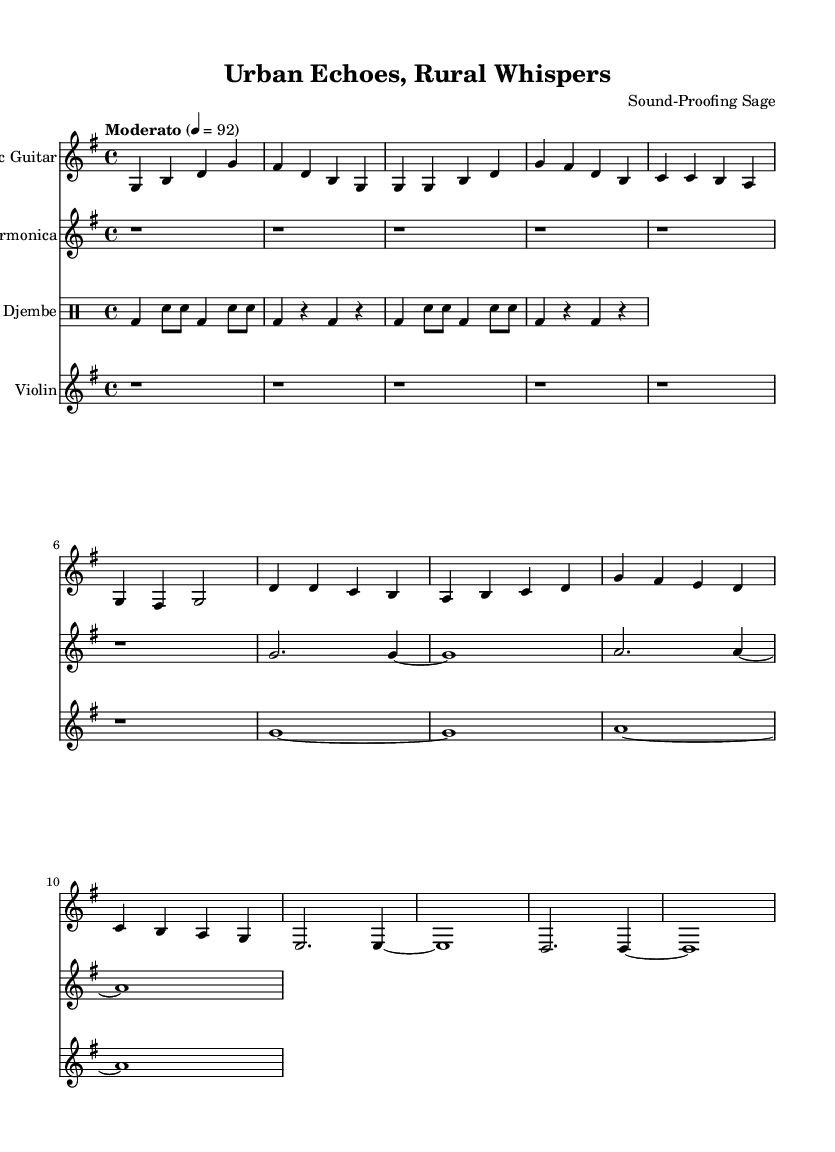What is the key signature of this music? The key signature shows one sharp, which indicates that the music is in G major.
Answer: G major What is the time signature of this music? The time signature is indicated as 4/4, meaning there are four beats in each measure and the quarter note gets one beat.
Answer: 4/4 What is the tempo marking in this piece? The tempo marking states "Moderato" with a metronome marking of quarter note = 92, suggesting a moderate speed for the music.
Answer: Moderato How many measures are in the acoustic guitar part? The acoustic guitar part consists of 8 measures as indicated by the grouping of notes and the line ending.
Answer: 8 Which instruments are included in this score? The score includes four instruments: Acoustic Guitar, Harmonica, Djembe, and Violin, as labeled at the beginning of each staff.
Answer: Acoustic Guitar, Harmonica, Djembe, Violin What section of the music displays a dense rhythm? The djembe section demonstrates a dense rhythm with its alternating bass and snare patterns, creating rhythmic complexity in the piece.
Answer: Djembe What musical elements contrast urban noise and rural serenity in this piece? The combination of percussive djembe rhythms with the softer, melodic lines from acoustic guitar and violin reflects the contrast between lively urban and tranquil rural sounds.
Answer: Acoustic Guitar, Violin (contrast) 